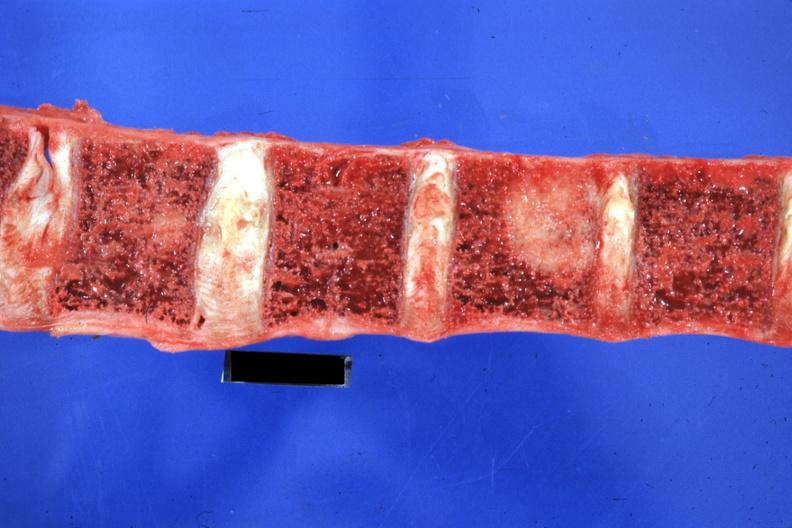does that show easily seen large lesion primary in tail of pancreas?
Answer the question using a single word or phrase. No 